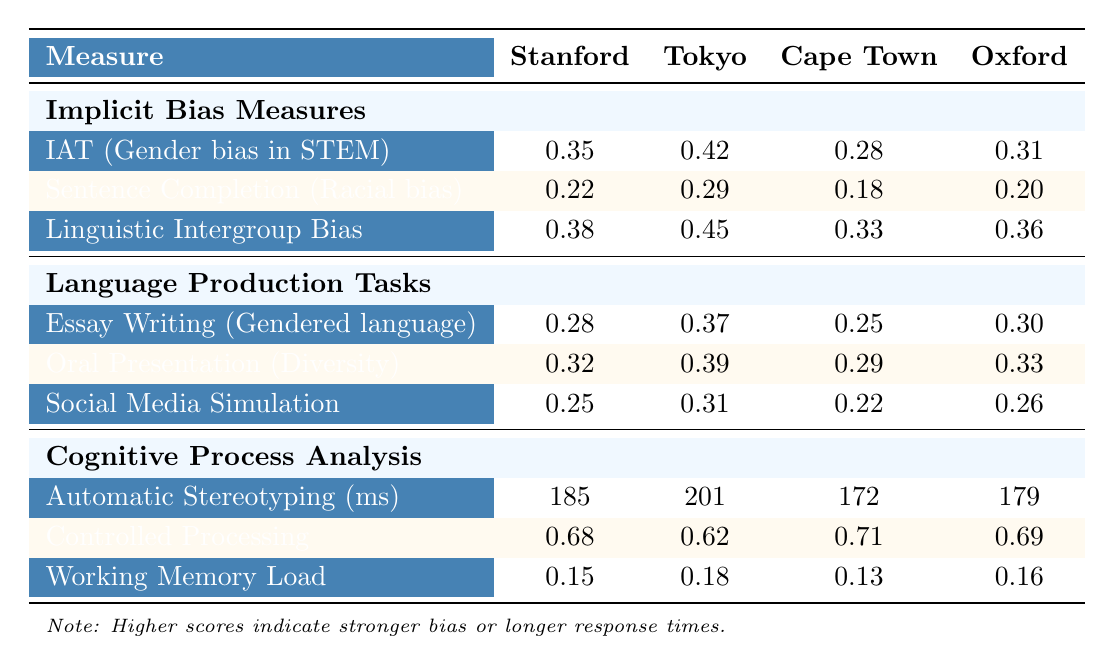What is the implicit bias score for gender bias in STEM fields at Stanford University? The table indicates that the score for the Implicit Association Test (IAT) related to gender bias in STEM fields at Stanford University is 0.35.
Answer: 0.35 Which university had the highest score for racial bias in leadership roles? By comparing the scores in the Sentence Completion Task for racial bias, Tokyo has the highest score of 0.29.
Answer: University of Tokyo What is the average score for linguistic intergroup bias across all universities? The average score is calculated by summing all scores (0.38 + 0.45 + 0.33 + 0.36) = 1.52, and dividing by the number of universities (4), giving us 1.52 / 4 = 0.38.
Answer: 0.38 Did Stanford University exhibit the lowest implicit bias score for gender bias in STEM fields among the listed universities? Stanford's score of 0.35 is lower than Tokyo's score of 0.42 and Cape Town's score of 0.28, but higher than Oxford's 0.31, so it is not the lowest overall.
Answer: No What is the difference in the automatic stereotyping response latency between Stanford University and Cape Town? The latency scores are 185 ms for Stanford and 172 ms for Cape Town. The difference is 185 - 172 = 13 ms.
Answer: 13 ms What is the overall bias indicator score for free-form essay writing on gendered language use across the universities? The overall average score for this task is calculated by (0.28 + 0.37 + 0.25 + 0.30) = 1.20 and dividing by 4, which equals 1.20 / 4 = 0.30.
Answer: 0.30 Which university showed the highest score in controlled processing effectiveness? The scores are 0.68 for Stanford, 0.62 for Tokyo, 0.71 for Cape Town, and 0.69 for Oxford. Cape Town had the highest score of 0.71.
Answer: University of Cape Town Is the mean score for social media post simulation regarding stereotypical language use across all universities higher than 0.25? The average score is (0.25 + 0.31 + 0.22 + 0.26) = 1.04, and when divided by 4 (1.04 / 4 = 0.26), this is indeed higher than 0.25.
Answer: Yes What is the highest implicit bias score in language production tasks across all universities? The scores for the tasks are 0.28, 0.32, and 0.25 for Stanford, 0.37, 0.39, and 0.31 for Tokyo and so on. The highest score is 0.39 from Tokyo in oral presentation.
Answer: 0.39 What is the total sample size of participants from all universities combined? The total sample size is calculated by adding the individual samples: 250 (Stanford) + 220 (Tokyo) + 180 (Cape Town) + 200 (Oxford) = 850 participants.
Answer: 850 